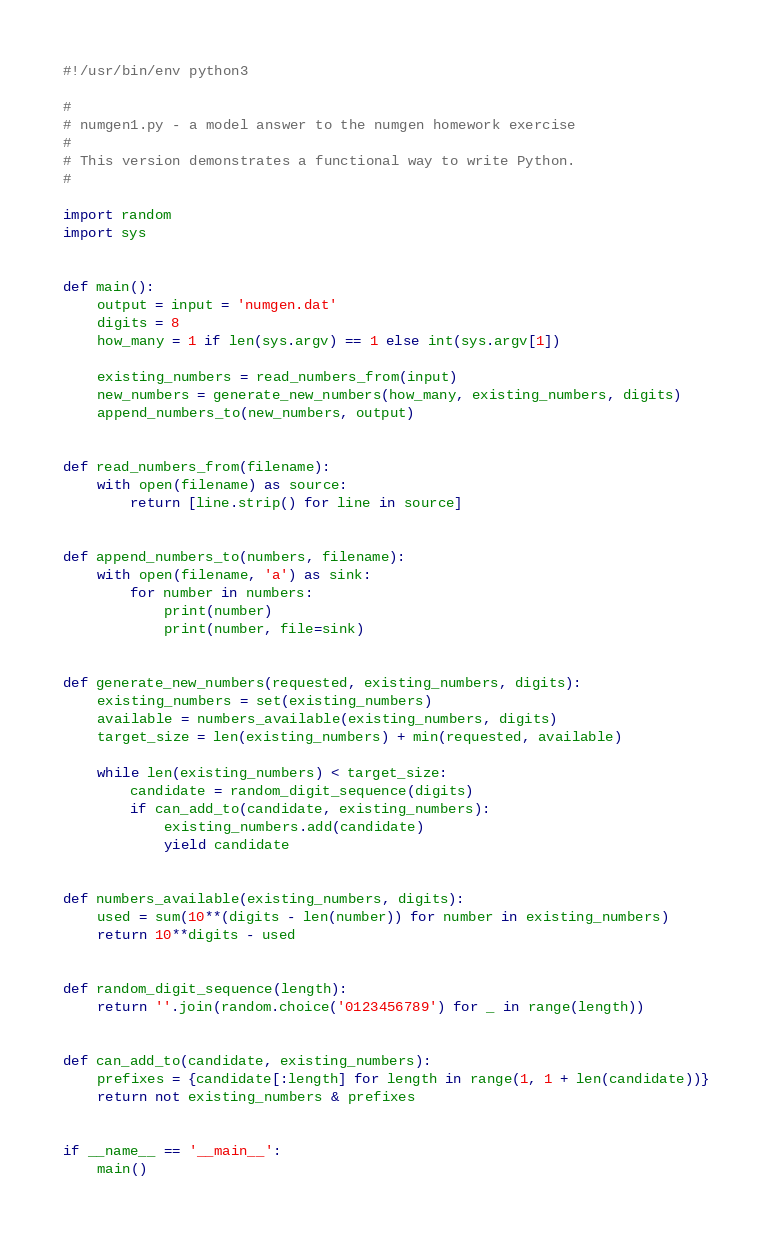<code> <loc_0><loc_0><loc_500><loc_500><_Python_>#!/usr/bin/env python3

#
# numgen1.py - a model answer to the numgen homework exercise
#
# This version demonstrates a functional way to write Python.
#

import random
import sys


def main():
    output = input = 'numgen.dat'
    digits = 8
    how_many = 1 if len(sys.argv) == 1 else int(sys.argv[1])

    existing_numbers = read_numbers_from(input)
    new_numbers = generate_new_numbers(how_many, existing_numbers, digits)
    append_numbers_to(new_numbers, output)


def read_numbers_from(filename):
    with open(filename) as source:
        return [line.strip() for line in source]


def append_numbers_to(numbers, filename):
    with open(filename, 'a') as sink:
        for number in numbers:
            print(number)
            print(number, file=sink)


def generate_new_numbers(requested, existing_numbers, digits):
    existing_numbers = set(existing_numbers)
    available = numbers_available(existing_numbers, digits)
    target_size = len(existing_numbers) + min(requested, available)

    while len(existing_numbers) < target_size:
        candidate = random_digit_sequence(digits)
        if can_add_to(candidate, existing_numbers):
            existing_numbers.add(candidate)
            yield candidate


def numbers_available(existing_numbers, digits):
    used = sum(10**(digits - len(number)) for number in existing_numbers)
    return 10**digits - used


def random_digit_sequence(length):
    return ''.join(random.choice('0123456789') for _ in range(length))


def can_add_to(candidate, existing_numbers):
    prefixes = {candidate[:length] for length in range(1, 1 + len(candidate))}
    return not existing_numbers & prefixes


if __name__ == '__main__':
    main()
</code> 